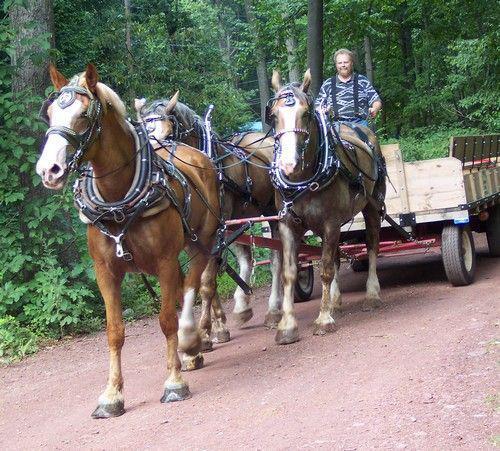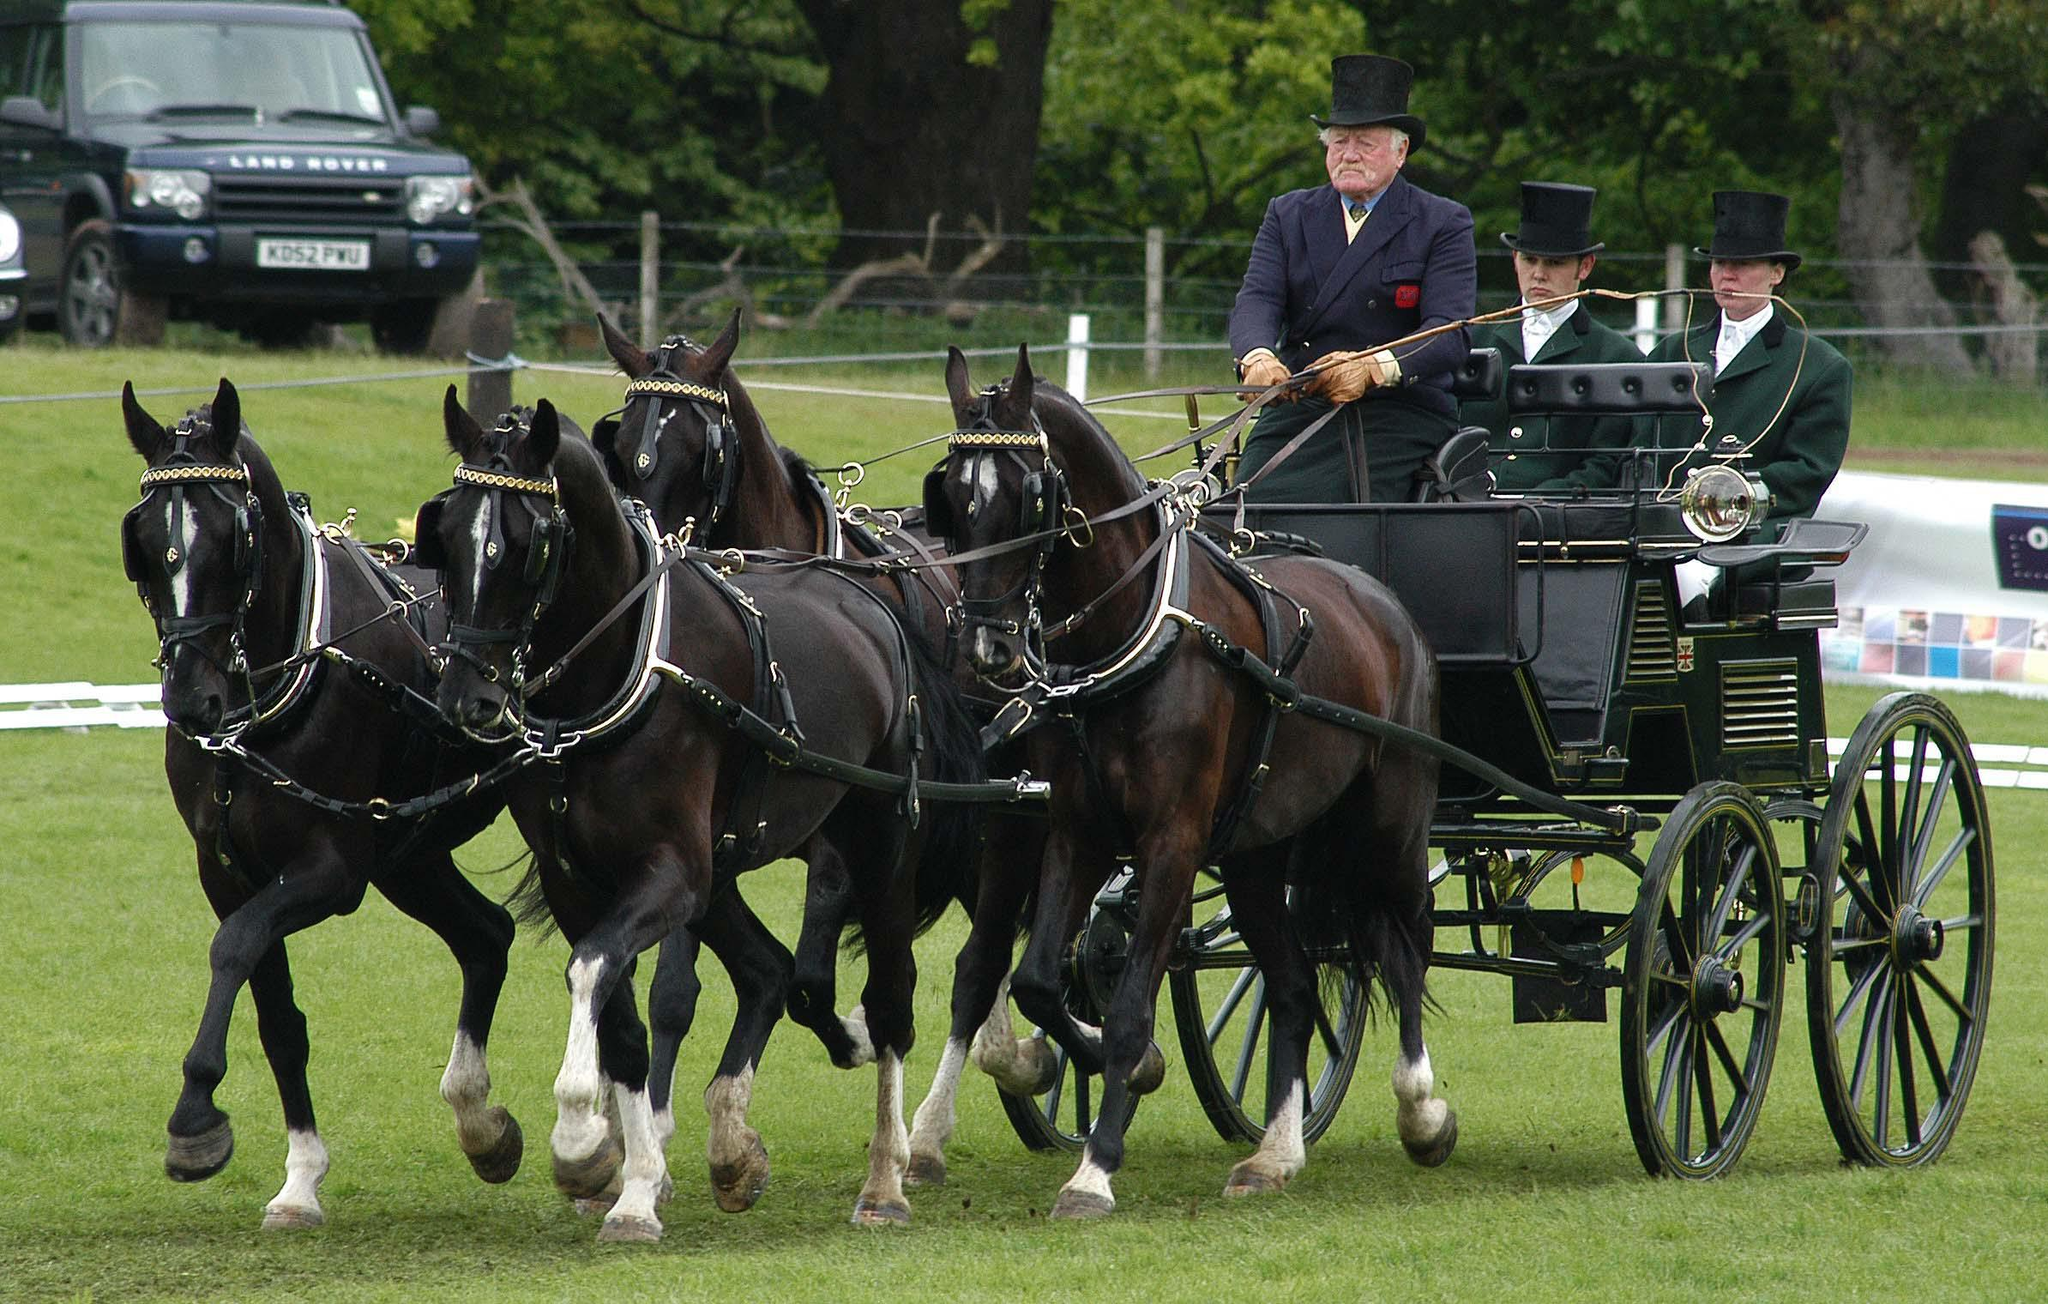The first image is the image on the left, the second image is the image on the right. For the images displayed, is the sentence "One image shows a wagon being pulled by four horses." factually correct? Answer yes or no. Yes. The first image is the image on the left, the second image is the image on the right. Examine the images to the left and right. Is the description "The horses in the image on the right are pulling a red carriage." accurate? Answer yes or no. No. 